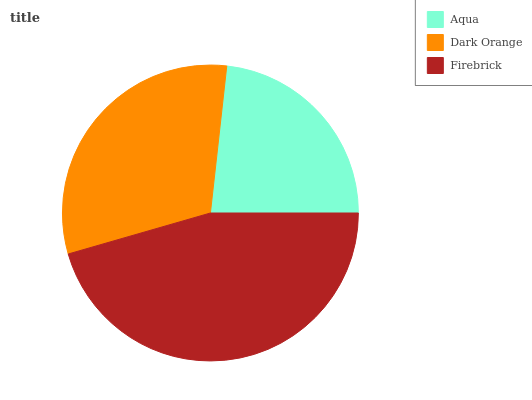Is Aqua the minimum?
Answer yes or no. Yes. Is Firebrick the maximum?
Answer yes or no. Yes. Is Dark Orange the minimum?
Answer yes or no. No. Is Dark Orange the maximum?
Answer yes or no. No. Is Dark Orange greater than Aqua?
Answer yes or no. Yes. Is Aqua less than Dark Orange?
Answer yes or no. Yes. Is Aqua greater than Dark Orange?
Answer yes or no. No. Is Dark Orange less than Aqua?
Answer yes or no. No. Is Dark Orange the high median?
Answer yes or no. Yes. Is Dark Orange the low median?
Answer yes or no. Yes. Is Aqua the high median?
Answer yes or no. No. Is Aqua the low median?
Answer yes or no. No. 